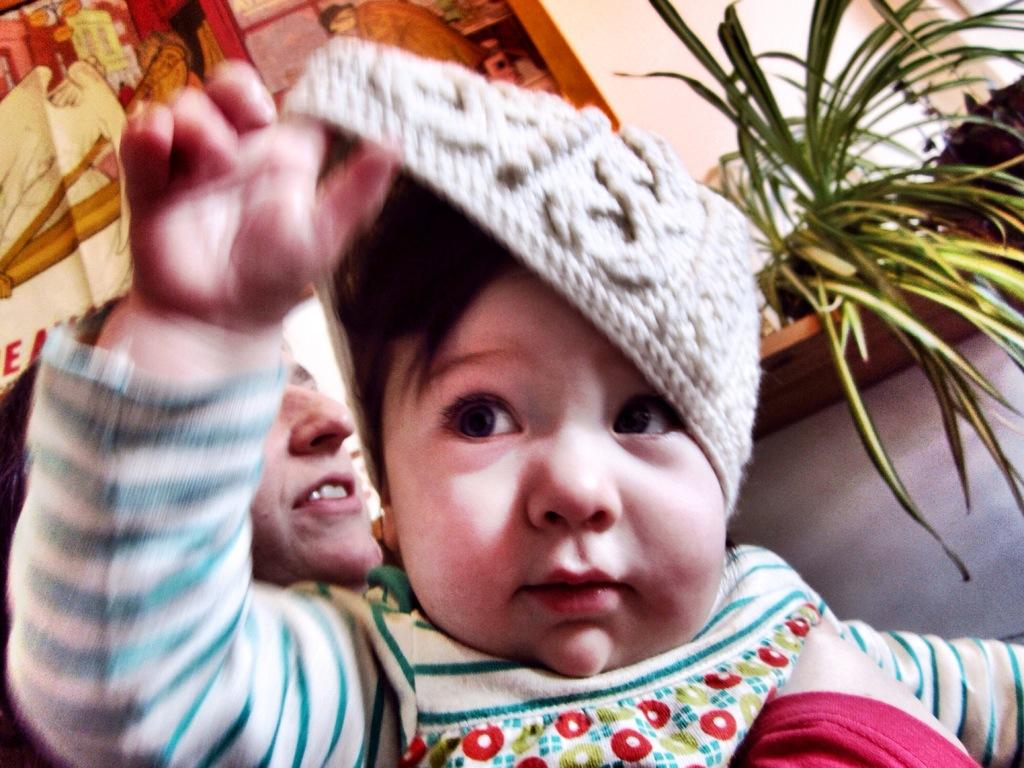Who or what can be seen in the image? There are people in the image. What else is present in the image besides the people? There are potted plants in the image. Can you describe the painted board on the wall in the image? Yes, there is a painted board on the wall in the image. How many rabbits can be seen balancing on the mass of the painted board in the image? There are no rabbits present in the image, and the painted board is not described as having a mass. 